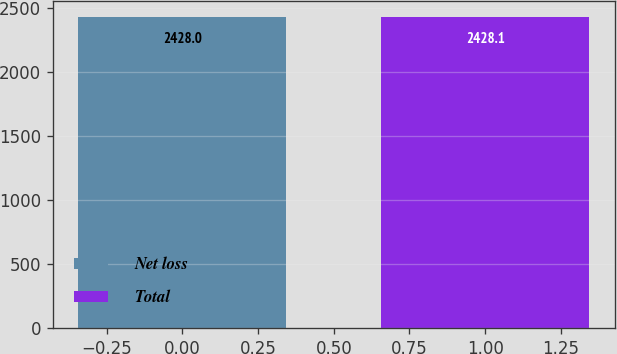Convert chart to OTSL. <chart><loc_0><loc_0><loc_500><loc_500><bar_chart><fcel>Net loss<fcel>Total<nl><fcel>2428<fcel>2428.1<nl></chart> 